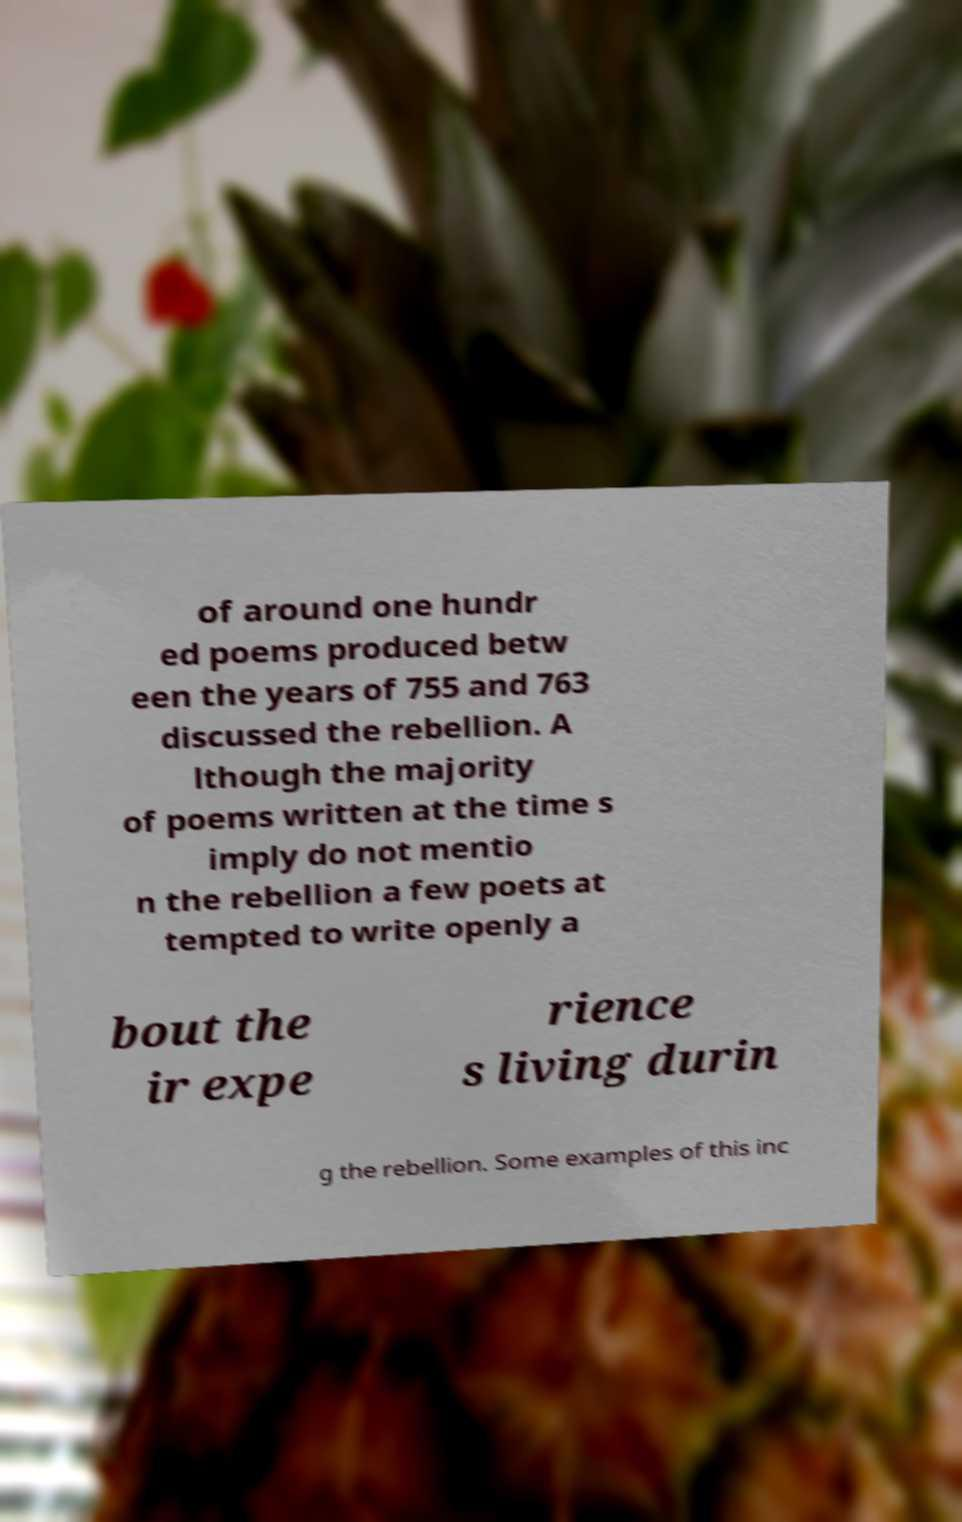For documentation purposes, I need the text within this image transcribed. Could you provide that? of around one hundr ed poems produced betw een the years of 755 and 763 discussed the rebellion. A lthough the majority of poems written at the time s imply do not mentio n the rebellion a few poets at tempted to write openly a bout the ir expe rience s living durin g the rebellion. Some examples of this inc 